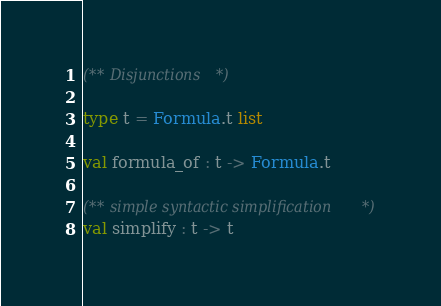<code> <loc_0><loc_0><loc_500><loc_500><_OCaml_>(** Disjunctions *)

type t = Formula.t list

val formula_of : t -> Formula.t

(** simple syntactic simplification *)
val simplify : t -> t
</code> 